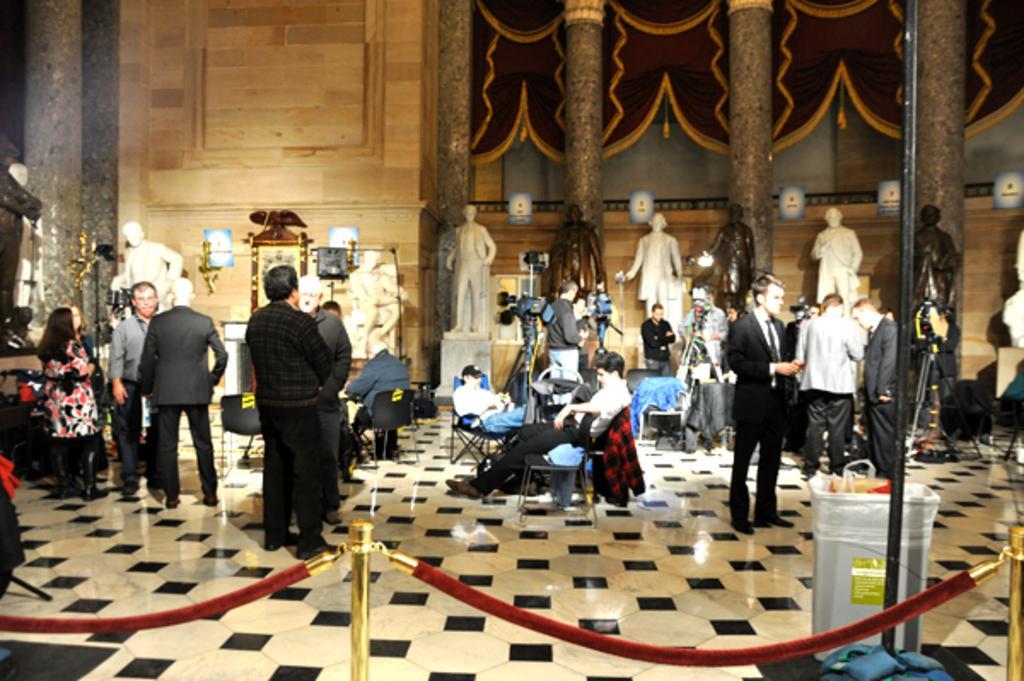Could you give a brief overview of what you see in this image? In the bottom of the image there are safety poles. In the center of the image there are many people. There are depictions of persons in the image. There are pillars. There is a wall. 